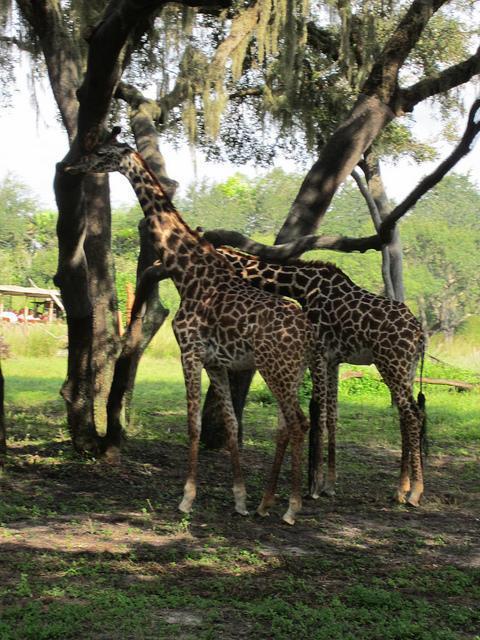How many giraffes are in the photo?
Give a very brief answer. 2. 